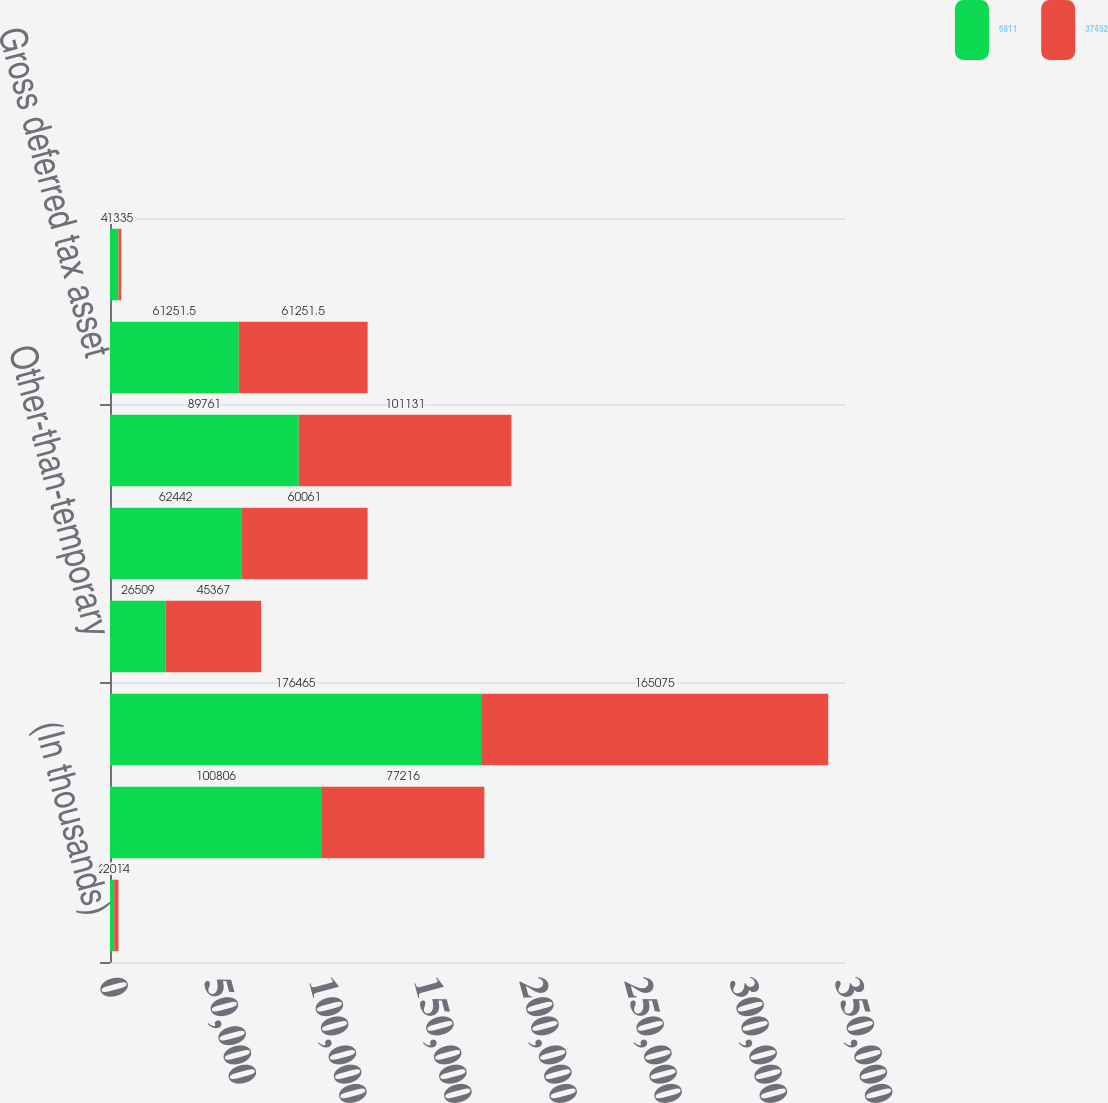Convert chart. <chart><loc_0><loc_0><loc_500><loc_500><stacked_bar_chart><ecel><fcel>(In thousands)<fcel>Loss reserve discounting<fcel>Unearned premiums<fcel>Other-than-temporary<fcel>Restricted stock units<fcel>Other<fcel>Gross deferred tax asset<fcel>Less valuation allowance<nl><fcel>6811<fcel>2015<fcel>100806<fcel>176465<fcel>26509<fcel>62442<fcel>89761<fcel>61251.5<fcel>4037<nl><fcel>37452<fcel>2014<fcel>77216<fcel>165075<fcel>45367<fcel>60061<fcel>101131<fcel>61251.5<fcel>1335<nl></chart> 